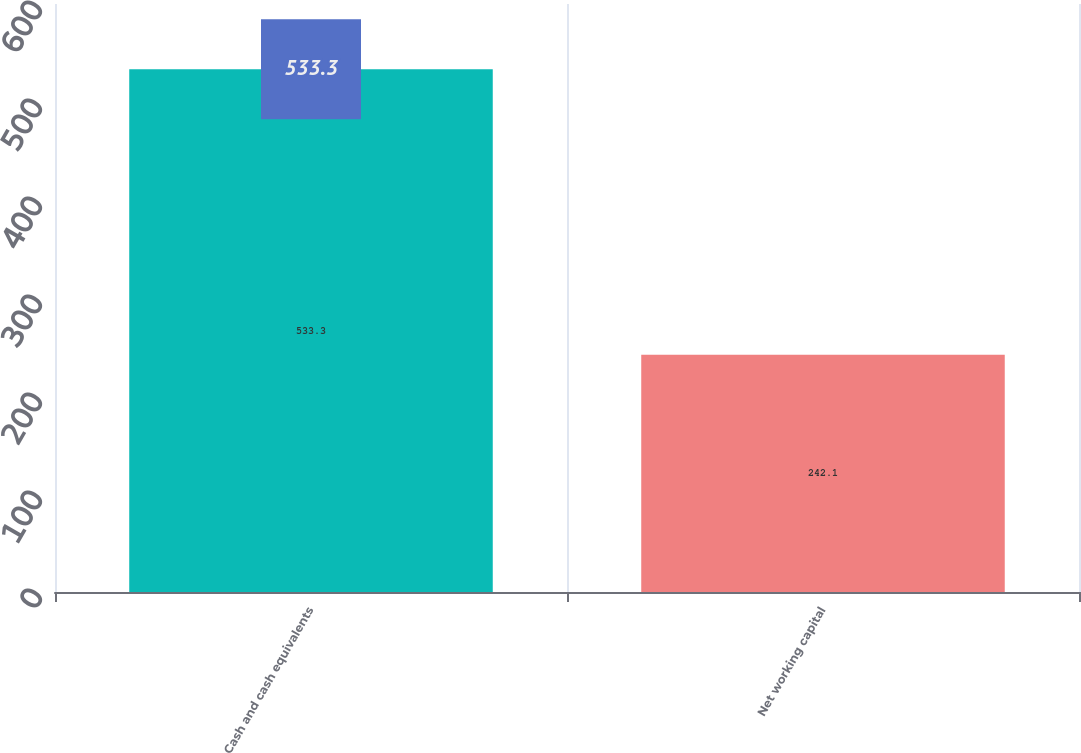Convert chart to OTSL. <chart><loc_0><loc_0><loc_500><loc_500><bar_chart><fcel>Cash and cash equivalents<fcel>Net working capital<nl><fcel>533.3<fcel>242.1<nl></chart> 